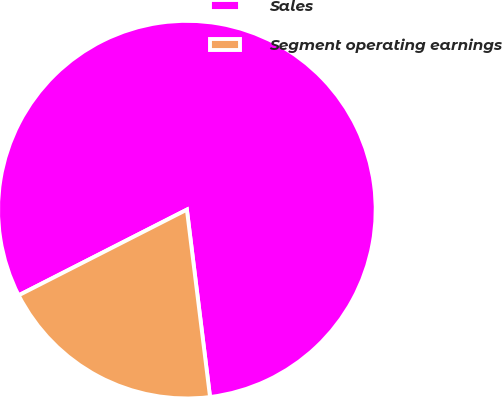Convert chart to OTSL. <chart><loc_0><loc_0><loc_500><loc_500><pie_chart><fcel>Sales<fcel>Segment operating earnings<nl><fcel>80.54%<fcel>19.46%<nl></chart> 